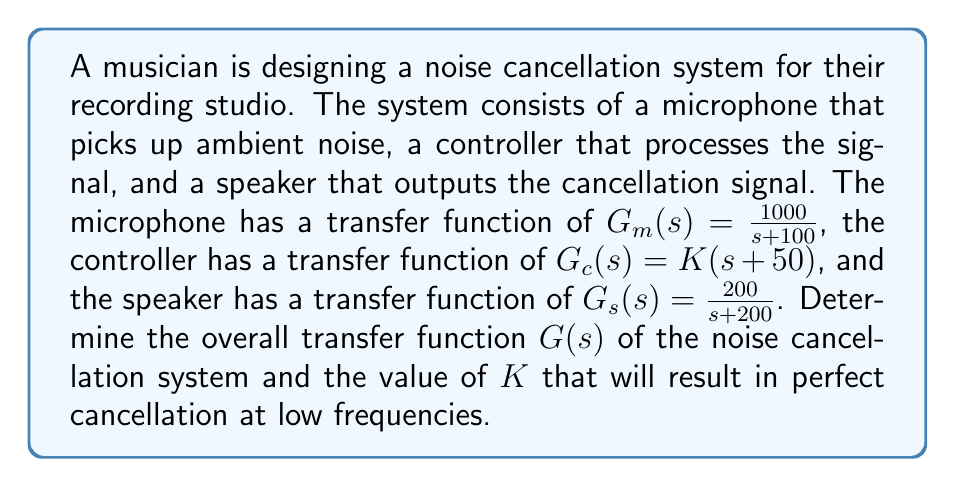Provide a solution to this math problem. To solve this problem, we'll follow these steps:

1) The overall transfer function of the noise cancellation system is the product of the individual transfer functions:

   $$G(s) = G_m(s) \cdot G_c(s) \cdot G_s(s)$$

2) Substituting the given transfer functions:

   $$G(s) = \frac{1000}{s + 100} \cdot K(s + 50) \cdot \frac{200}{s + 200}$$

3) Multiplying these together:

   $$G(s) = \frac{200000K(s + 50)}{(s + 100)(s + 200)}$$

4) For perfect cancellation at low frequencies, the gain of the system should be -1 when $s$ approaches 0. This means:

   $$\lim_{s \to 0} G(s) = -1$$

5) Evaluating this limit:

   $$\lim_{s \to 0} \frac{200000K(s + 50)}{(s + 100)(s + 200)} = \frac{200000K \cdot 50}{100 \cdot 200} = -1$$

6) Solving for K:

   $$50K = -\frac{1}{20}$$
   $$K = -\frac{1}{1000}$$

Therefore, the value of K for perfect cancellation at low frequencies is $-\frac{1}{1000}$.
Answer: The overall transfer function of the noise cancellation system is:

$$G(s) = \frac{200000K(s + 50)}{(s + 100)(s + 200)}$$

The value of K for perfect cancellation at low frequencies is $K = -\frac{1}{1000}$. 